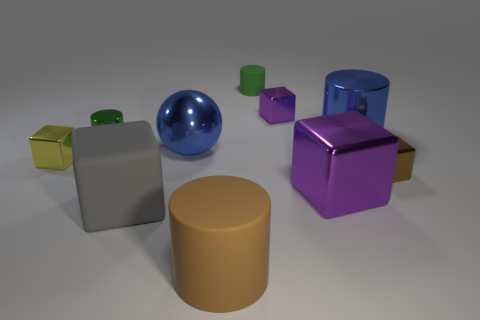Subtract 1 blocks. How many blocks are left? 4 Subtract all yellow shiny blocks. How many blocks are left? 4 Subtract all gray cubes. How many cubes are left? 4 Subtract all cyan blocks. Subtract all gray cylinders. How many blocks are left? 5 Subtract all cylinders. How many objects are left? 6 Add 2 shiny balls. How many shiny balls exist? 3 Subtract 1 brown cylinders. How many objects are left? 9 Subtract all large purple objects. Subtract all big gray matte objects. How many objects are left? 8 Add 8 big brown matte things. How many big brown matte things are left? 9 